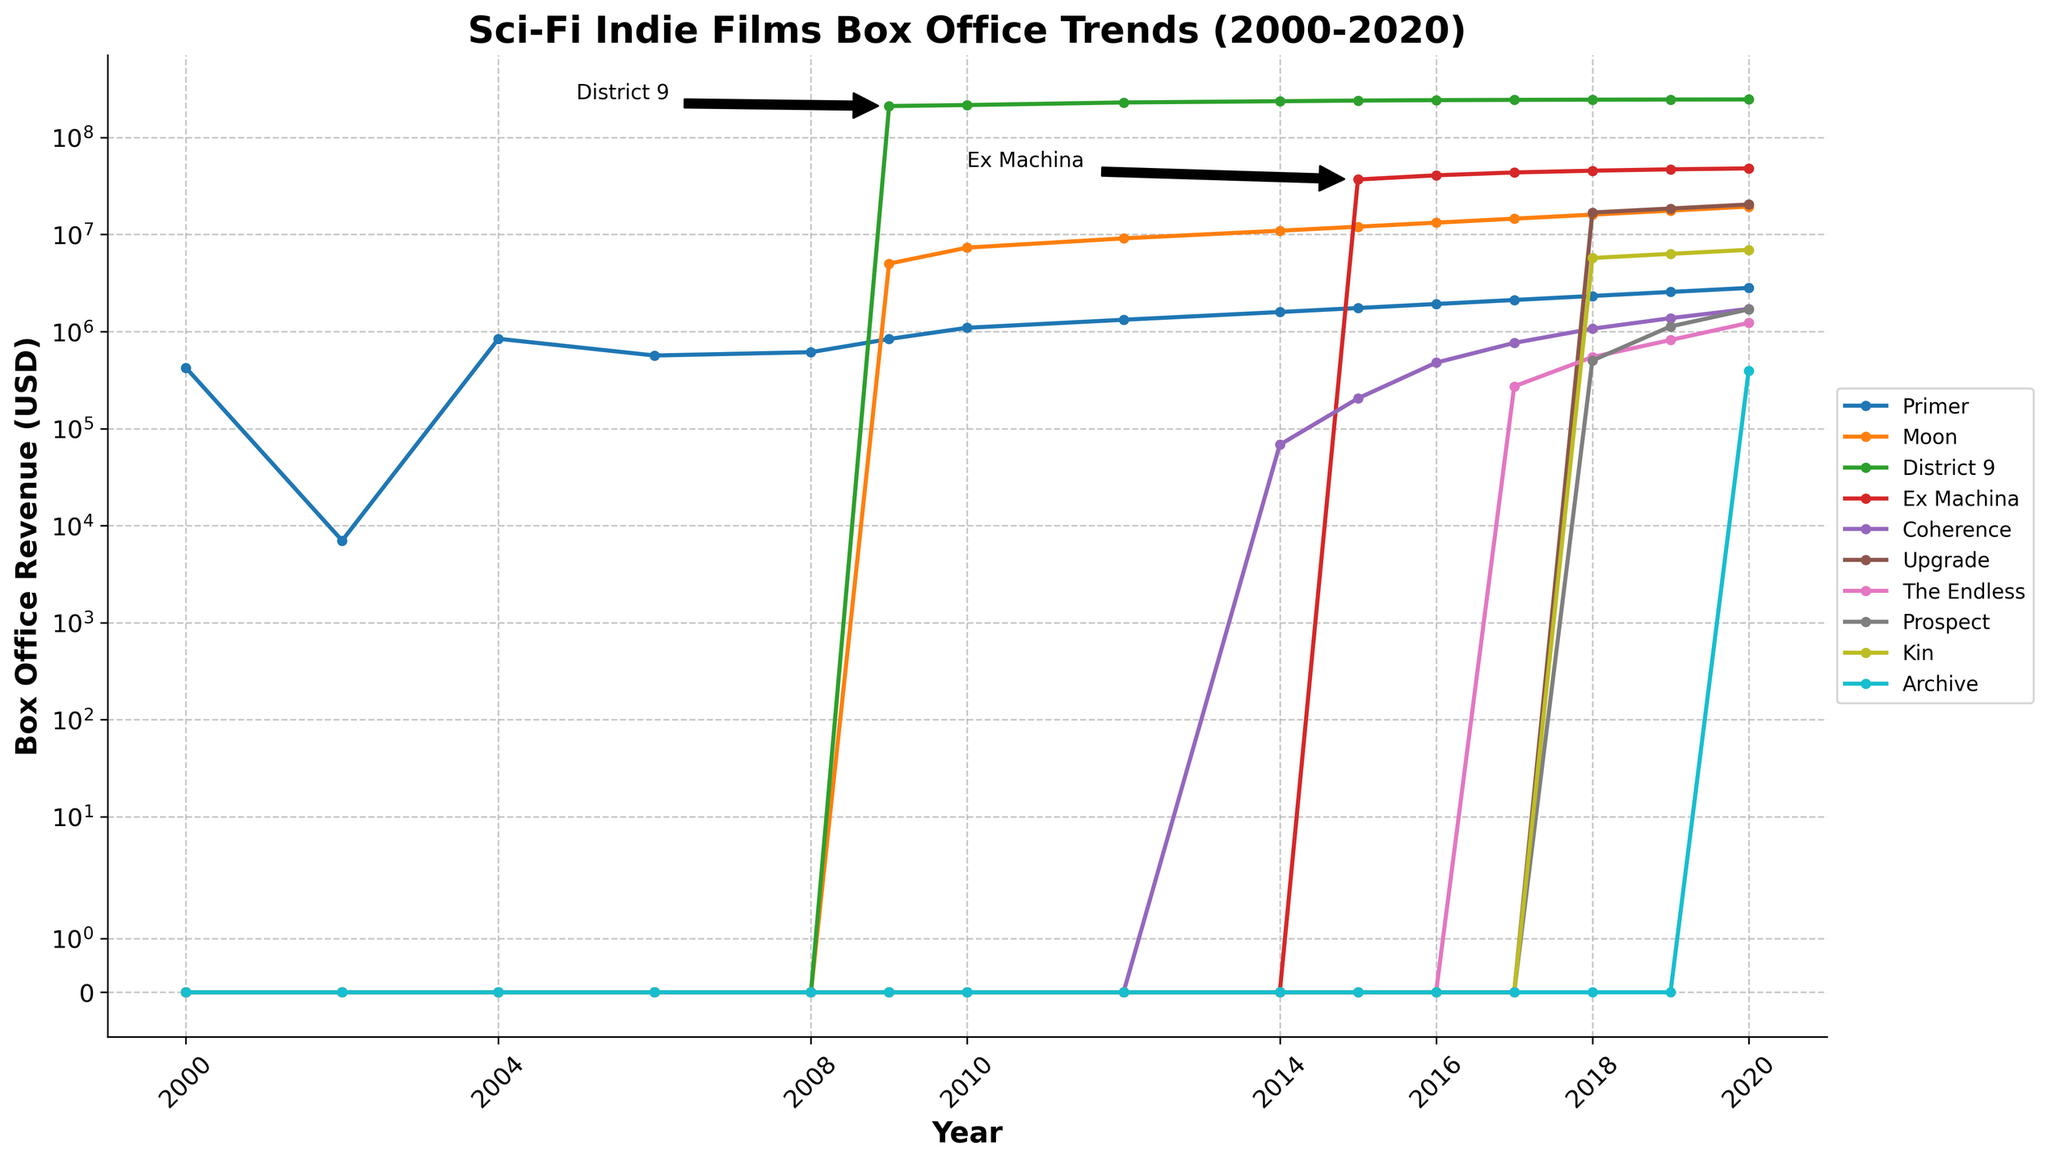What year did 'District 9' achieve its peak box office revenue according to the figure? The annotations on the line for 'District 9' and the data points in the figure show the peak box office revenue for 'District 9' was in the year 2012, at over 229 million USD. The subsequent years show revenue still in the 240+ million range, but the exact peak is at its highest annotated point in 2012.
Answer: 2012 Which movie among the listed shows the least revenue in any year, and what that figure was? By examining the different plotlines, 'Kin' in 2018 shows the least revenue among all movies in the provided years, as it had 0 revenue until 2018 and then had a low point at approximately 572,162 USD.
Answer: Kin, 572,162 USD in 2018 Between 'Moon' and 'Ex Machina,' which one had a higher growth rate over the first three years of their revenue history? Growth rate can be calculated by finding the difference in revenue from the movie's release year and subsequent years. 'Moon' starts in 2009 with a revenue of roughly 5 million USD and grows to about 11 million USD in 2014. 'Ex Machina' starts in 2015 with roughly 36 million USD and reaches about 48 million USD in 2020. Calculating growth rates: Moon 11 million - 5 million = 6 million over span of 5 years, whereas Ex Machina 48 million - 36 million = 12 million over span of 5 years makes 'Ex Machina' have a higher growth rate.
Answer: Ex Machina What was the combined revenue of 'Primer' and 'Moon' in 2016? Referring to the plot data for the year 2016, 'Primer' had a revenue of 1,921,338 USD and 'Moon' had a revenue of 13,235,126 USD. Adding these together: 1,921,338 + 13,235,126 = 15,156,464 USD.
Answer: 15,156,464 USD Is there any year where three movies ('Primer,' 'Moon,' and 'District 9') all showed revenue, and what was the combined revenue for that year? Checking the revenue lines, in 2010 all three movies had revenues: Primer 1,092,847 USD, Moon 7,322,508 USD and District 9 215,815,448 USD. Summing these: 1,092,847 + 7,322,508 + 215,815,448 = 224,230,803 USD.
Answer: 224,230,803 USD Over what years does ‘Ex Machina’ have higher revenue than ‘Moon’? Tracing the lines for these two movies, we see that ‘Ex Machina’ started in 2015 and already had significant revenue. For the year 2015-2020, 'Ex Machina' consistently had higher revenues compared to 'Moon.'
Answer: 2015-2020 Which two movies had the closest revenues in the year 2018, and what were these amounts? Looking at the figure for 2018, 'The Endless' and 'Prospect' had revenues of about 545,058 USD and 501,878 USD respectively, which are closest in value.
Answer: The Endless and Prospect, 545,058 USD and 501,878 USD Which movie had a notable rise in revenue between 2017 and 2018? From the visual inspection, 'The Endless' shows a significant increase in revenue from almost zero in 2017 to over 500K USD in 2018. This is the most notable rise among the movies displayed.
Answer: The Endless How many years did it take for 'Moon' to reach approximately half its peak revenue starting from 2009? 'Moon' started in 2009 with a value and peaked later, half of its highest point (estimated at 16 million peak) is around 8 million. It took from 2009 to around 2014 where it reached close to 8 million USD.
Answer: 5 years 